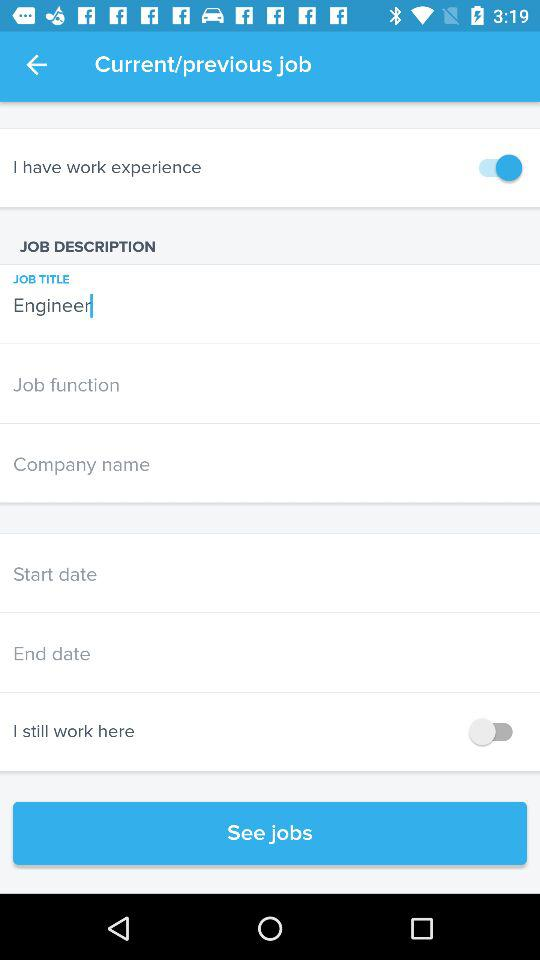How many input fields are there for dates?
Answer the question using a single word or phrase. 2 